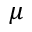<formula> <loc_0><loc_0><loc_500><loc_500>\mu</formula> 